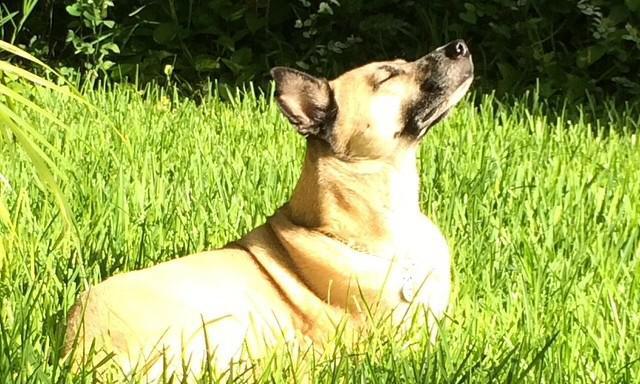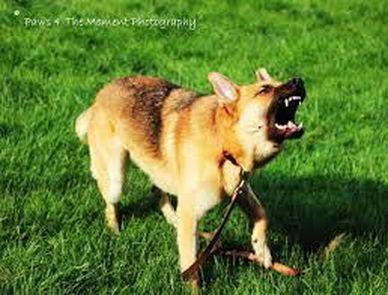The first image is the image on the left, the second image is the image on the right. For the images displayed, is the sentence "There is a human touching one of the dogs." factually correct? Answer yes or no. No. The first image is the image on the left, the second image is the image on the right. Evaluate the accuracy of this statement regarding the images: "One dog with a dark muzzle is reclining on the grass, and at least one dog has an opened, non-snarling mouth.". Is it true? Answer yes or no. No. 